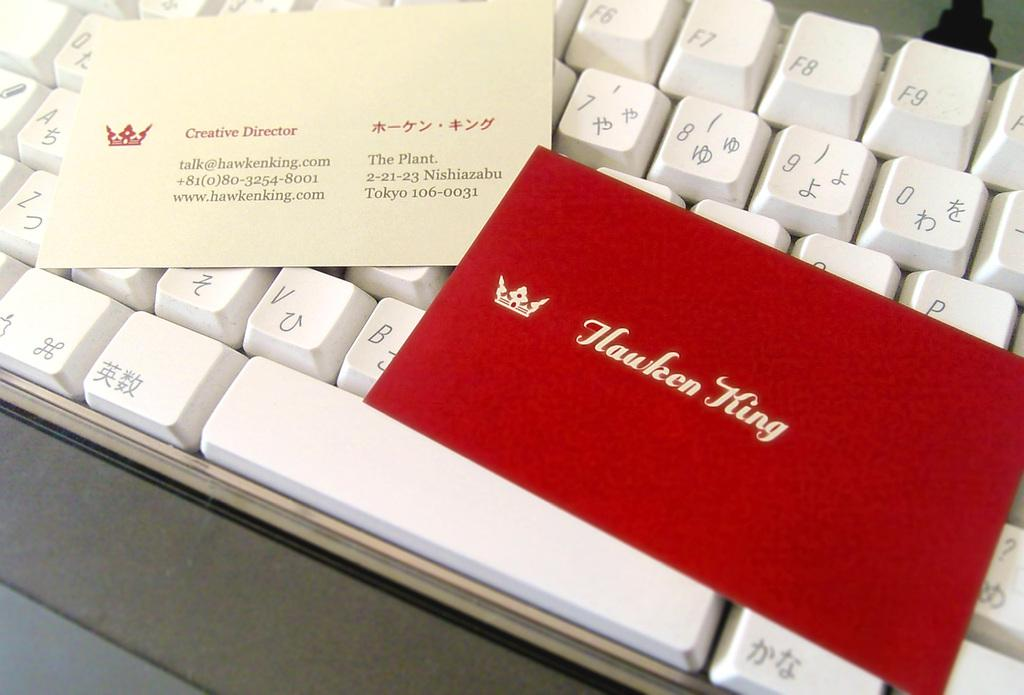<image>
Summarize the visual content of the image. A white keyboard has a business card on it that says Creative Director Hawken King. 